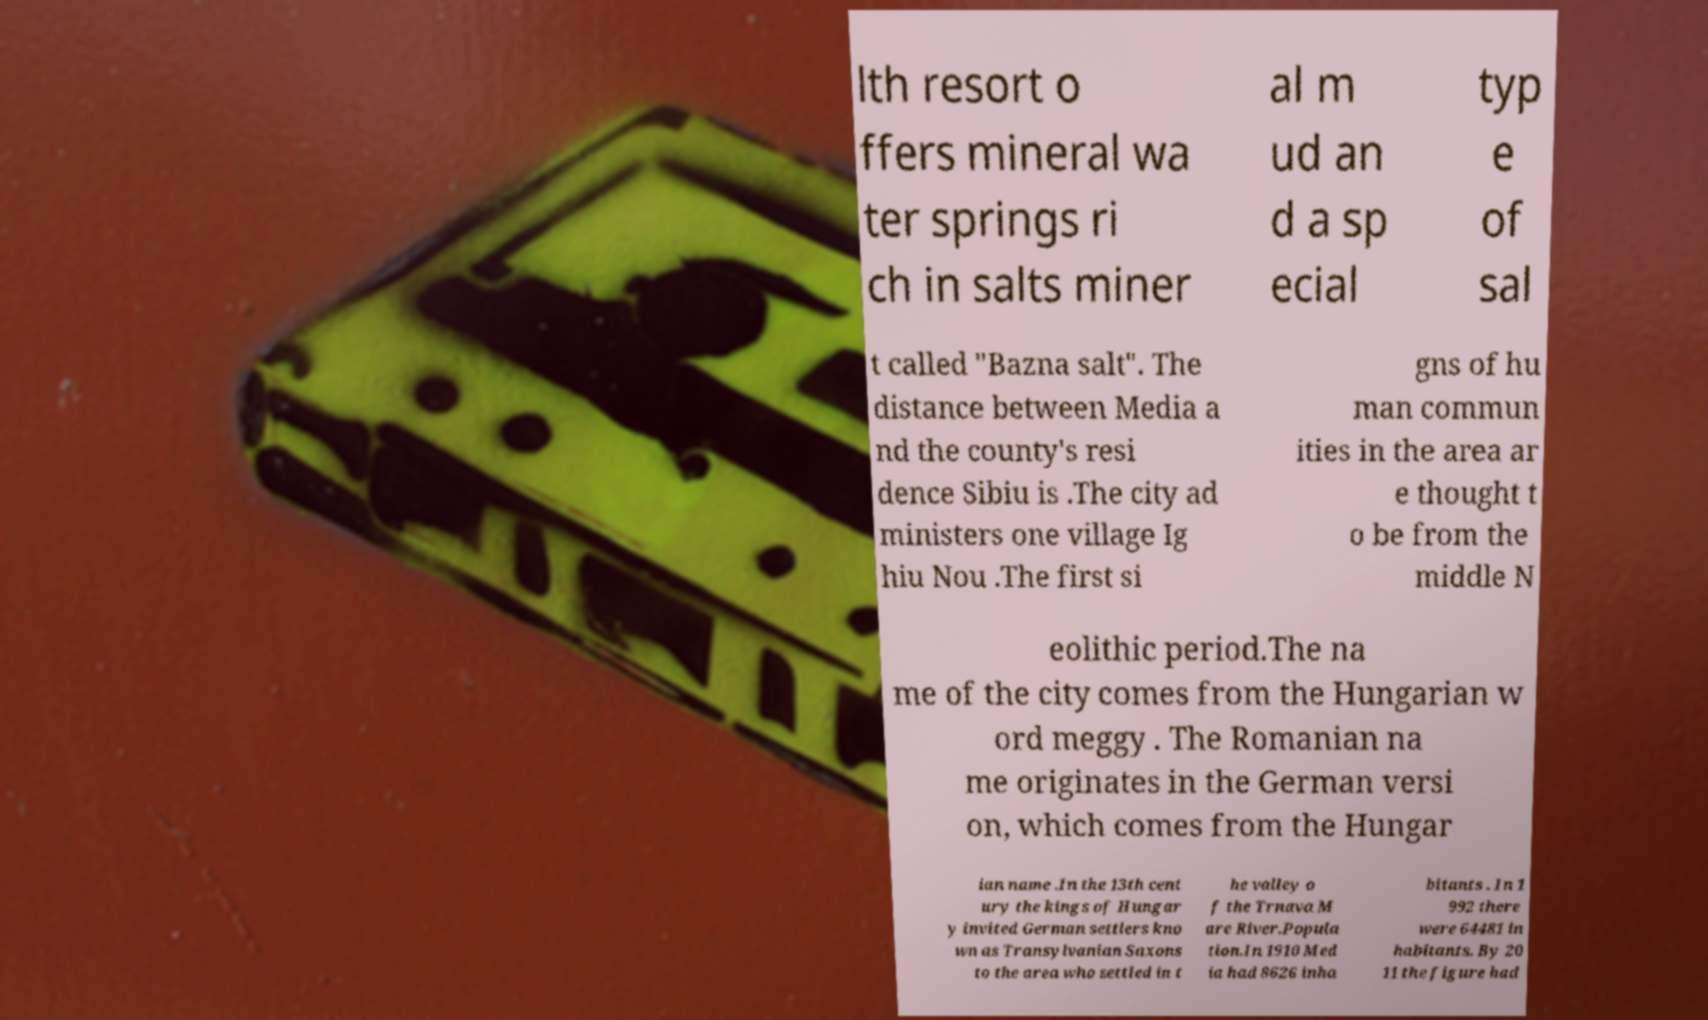Please identify and transcribe the text found in this image. lth resort o ffers mineral wa ter springs ri ch in salts miner al m ud an d a sp ecial typ e of sal t called "Bazna salt". The distance between Media a nd the county's resi dence Sibiu is .The city ad ministers one village Ig hiu Nou .The first si gns of hu man commun ities in the area ar e thought t o be from the middle N eolithic period.The na me of the city comes from the Hungarian w ord meggy . The Romanian na me originates in the German versi on, which comes from the Hungar ian name .In the 13th cent ury the kings of Hungar y invited German settlers kno wn as Transylvanian Saxons to the area who settled in t he valley o f the Trnava M are River.Popula tion.In 1910 Med ia had 8626 inha bitants . In 1 992 there were 64481 in habitants. By 20 11 the figure had 